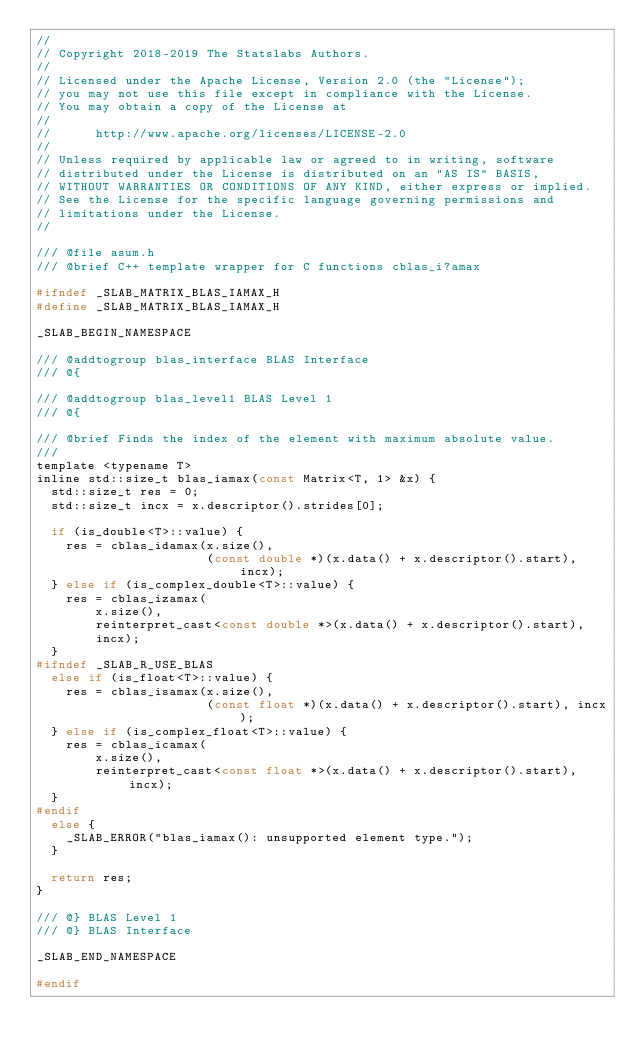<code> <loc_0><loc_0><loc_500><loc_500><_C_>//
// Copyright 2018-2019 The Statslabs Authors.
//
// Licensed under the Apache License, Version 2.0 (the "License");
// you may not use this file except in compliance with the License.
// You may obtain a copy of the License at
//
//      http://www.apache.org/licenses/LICENSE-2.0
//
// Unless required by applicable law or agreed to in writing, software
// distributed under the License is distributed on an "AS IS" BASIS,
// WITHOUT WARRANTIES OR CONDITIONS OF ANY KIND, either express or implied.
// See the License for the specific language governing permissions and
// limitations under the License.
//

/// @file asum.h
/// @brief C++ template wrapper for C functions cblas_i?amax

#ifndef _SLAB_MATRIX_BLAS_IAMAX_H
#define _SLAB_MATRIX_BLAS_IAMAX_H

_SLAB_BEGIN_NAMESPACE

/// @addtogroup blas_interface BLAS Interface
/// @{

/// @addtogroup blas_level1 BLAS Level 1
/// @{

/// @brief Finds the index of the element with maximum absolute value.
///
template <typename T>
inline std::size_t blas_iamax(const Matrix<T, 1> &x) {
  std::size_t res = 0;
  std::size_t incx = x.descriptor().strides[0];

  if (is_double<T>::value) {
    res = cblas_idamax(x.size(),
                       (const double *)(x.data() + x.descriptor().start), incx);
  } else if (is_complex_double<T>::value) {
    res = cblas_izamax(
        x.size(),
        reinterpret_cast<const double *>(x.data() + x.descriptor().start),
        incx);
  }
#ifndef _SLAB_R_USE_BLAS
  else if (is_float<T>::value) {
    res = cblas_isamax(x.size(),
                       (const float *)(x.data() + x.descriptor().start), incx);
  } else if (is_complex_float<T>::value) {
    res = cblas_icamax(
        x.size(),
        reinterpret_cast<const float *>(x.data() + x.descriptor().start), incx);
  }
#endif
  else {
    _SLAB_ERROR("blas_iamax(): unsupported element type.");
  }

  return res;
}

/// @} BLAS Level 1
/// @} BLAS Interface

_SLAB_END_NAMESPACE

#endif
</code> 